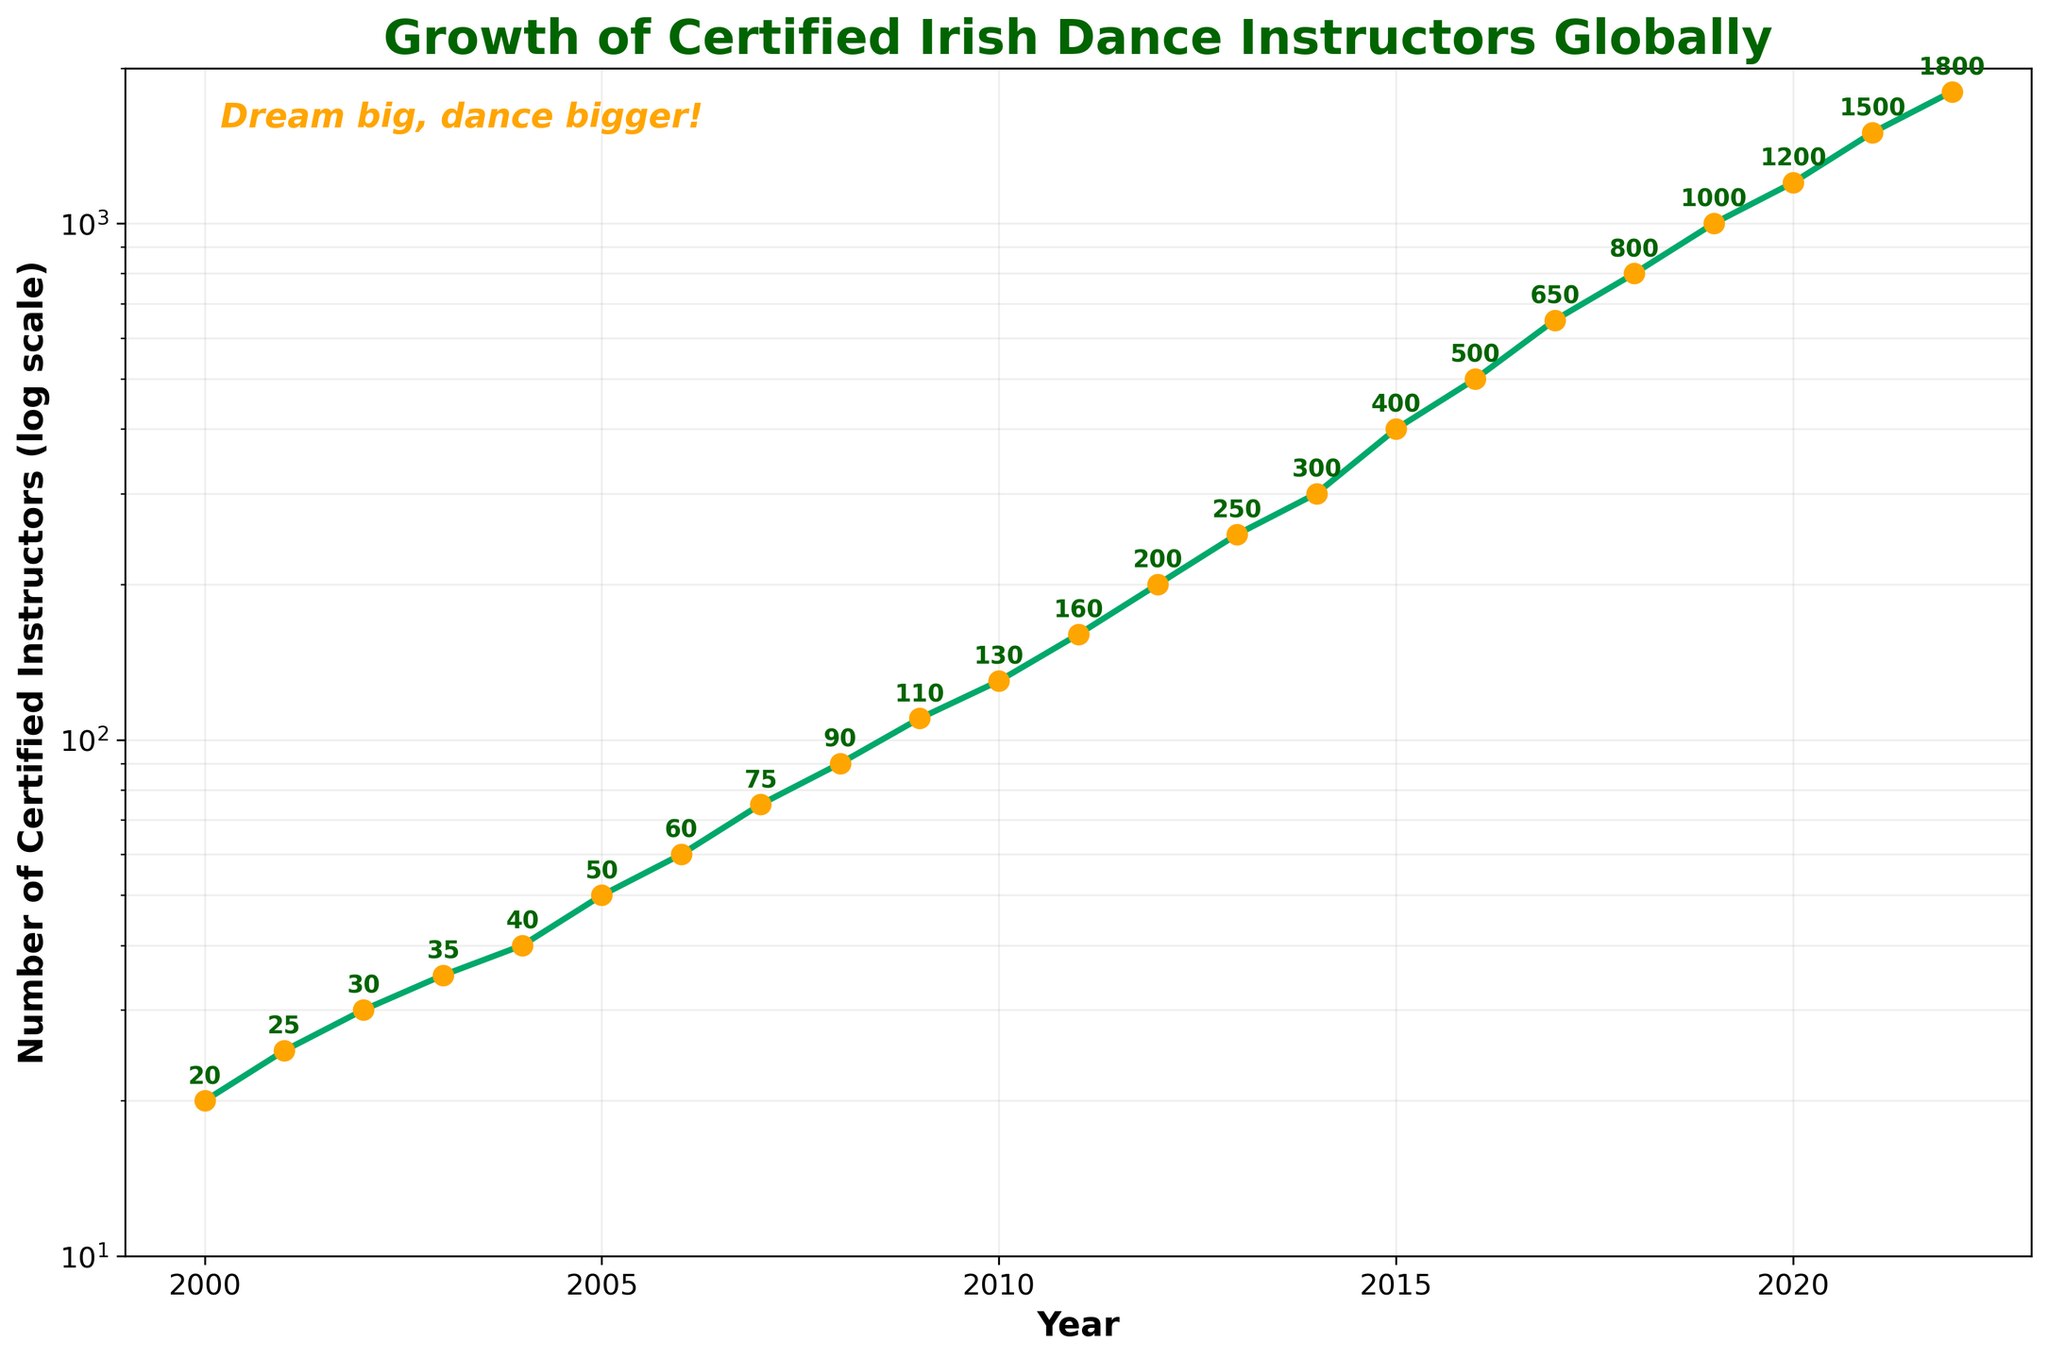What is the title of the plot? The title of the plot is text located at the top center of the figure. The title is written in large, bold font to grab attention and describe what the plot is about.
Answer: "Growth of Certified Irish Dance Instructors Globally" What is the range of years displayed on the x-axis? The x-axis spans from the smallest year value (2000 or earlier) to the largest year value (2022 or later). These are written along the horizontal axis.
Answer: 2000 - 2022 How many certified instructors were there in the year 2010? Locate the year 2010 along the x-axis, then trace upwards to the corresponding y-axis value which is annotated beside the plotted point.
Answer: 130 How does the number of certified instructors compare between 2006 and 2016? Identify the y-axis values for the years 2006 and 2016. The number of instructors in 2006 is labeled beside the year 2006, and similarly for 2016. Compare the two values to understand how they changed.
Answer: 60 in 2006 and 500 in 2016 What year had the first occurrence of over 1000 certified instructors? Find the earliest year where the y-axis value is greater than 1000 by looking for the first labeled point that exceeds this number.
Answer: 2019 Which year experienced the largest single-year increase in the number of certified instructors? Look at the year-to-year increments in the y-axis values; the largest increase is the one with the greatest difference between consecutive years. This can be numerically verified by checking each year's progression.
Answer: Between 2015 and 2016 What is the color of the line connecting the data points? The color of the line connecting the data points is uniform and is consistent throughout the plot, enhancing the line's visibility against the background. It's specified visually from the plot's appearance.
Answer: Green How many data points are plotted on this chart? Count the total number of plotted points, which correspond to the total number of data entries provided, each representing a year.
Answer: 23 What is the purpose of using a log scale on the y-axis in this plot? A log scale is used to represent data that spans several orders of magnitude more clearly. It compresses large range data into a more manageable visual space, highlighting the proportional differences between values more distinctly.
Answer: To clearly represent data spanning several orders of magnitude What is the approximate doubling period of certified instructors between 2002 and 2010? Determine the initial value in 2002 and then find the interval when it next approximately doubles in 2010. Perform this calculation using the y-values: in 2002, there are 30 instructors and in 2010, about 130, close to quadrupling, suggesting periods of rapid growth.
Answer: Approximately every 3 years 